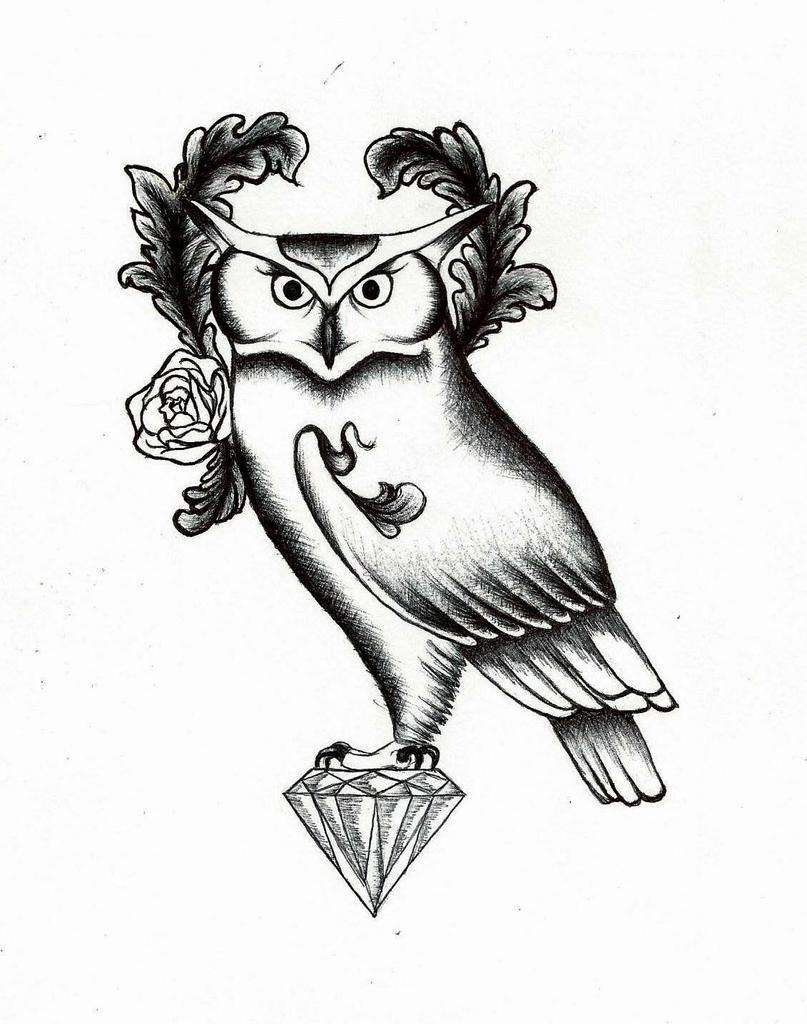What type of animal is depicted in the image? There is a depiction of an owl in the image. What other objects or symbols can be seen in the image? There is a depiction of a diamond and a flower in the image. What is the color scheme of the image? The image is black and white in color. What type of wool is used to create the texture of the owl in the image? There is no wool present in the image, as it is a black and white depiction of an owl. How many stones are visible in the image? There are no stones visible in the image; it features a depiction of an owl, a diamond, and a flower. 